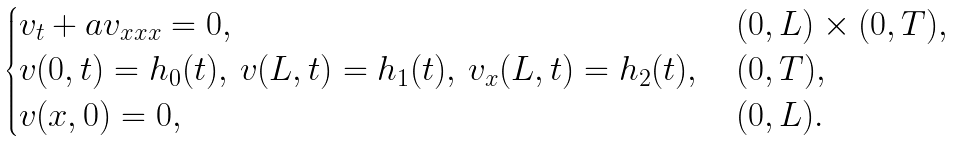<formula> <loc_0><loc_0><loc_500><loc_500>\begin{cases} v _ { t } + a v _ { x x x } = 0 , & \, ( 0 , L ) \times ( 0 , T ) , \\ v ( 0 , t ) = h _ { 0 } ( t ) , \, v ( L , t ) = h _ { 1 } ( t ) , \, v _ { x } ( L , t ) = h _ { 2 } ( t ) , & \, ( 0 , T ) , \\ v ( x , 0 ) = 0 , & \, ( 0 , L ) . \end{cases}</formula> 